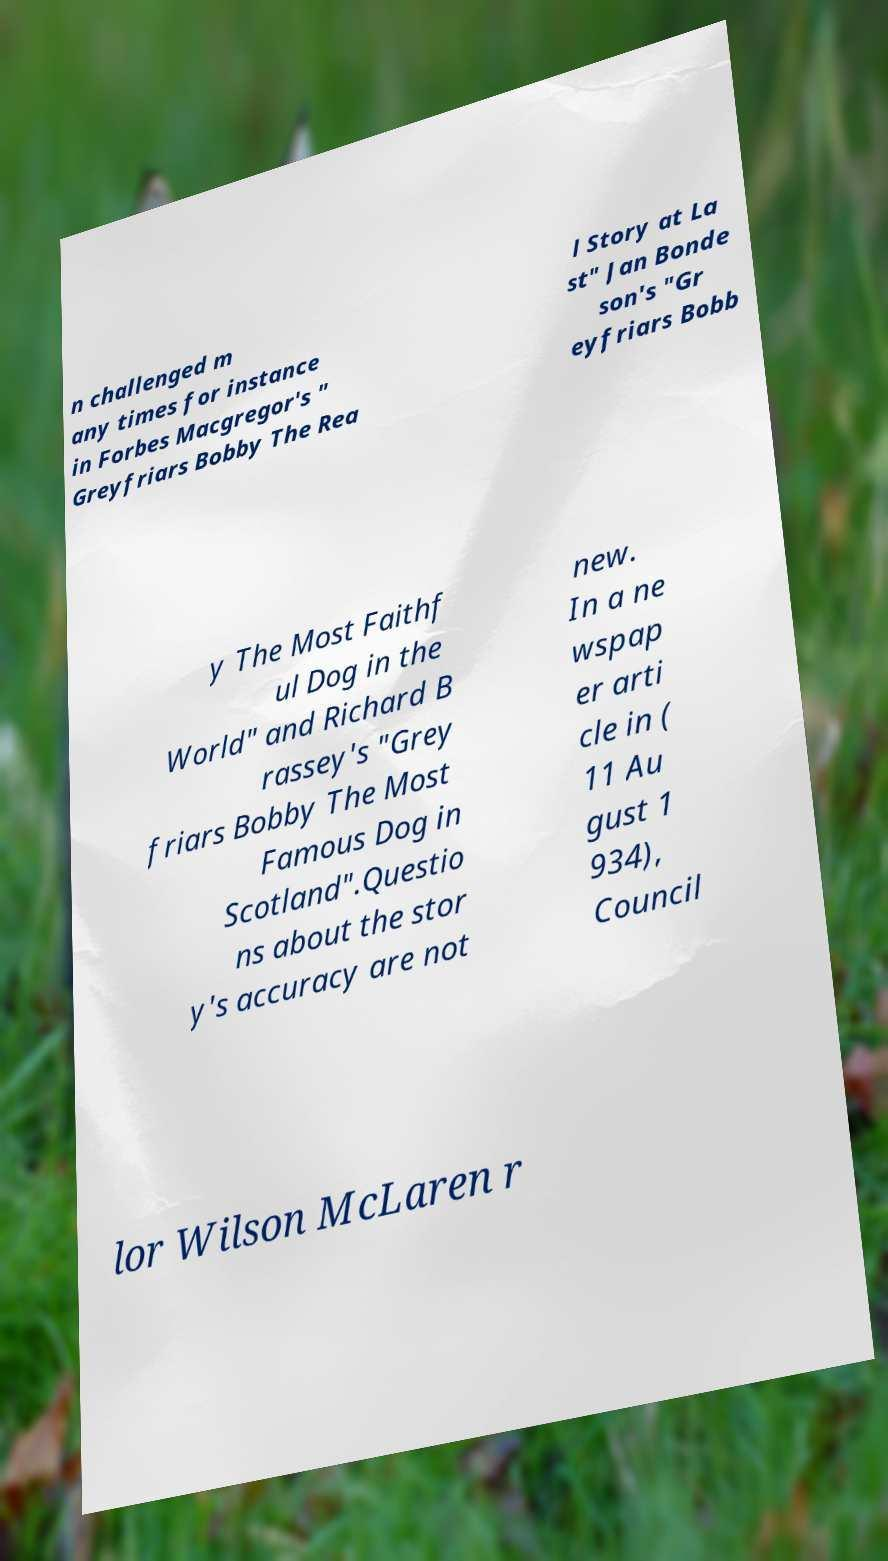What messages or text are displayed in this image? I need them in a readable, typed format. n challenged m any times for instance in Forbes Macgregor's " Greyfriars Bobby The Rea l Story at La st" Jan Bonde son's "Gr eyfriars Bobb y The Most Faithf ul Dog in the World" and Richard B rassey's "Grey friars Bobby The Most Famous Dog in Scotland".Questio ns about the stor y's accuracy are not new. In a ne wspap er arti cle in ( 11 Au gust 1 934), Council lor Wilson McLaren r 